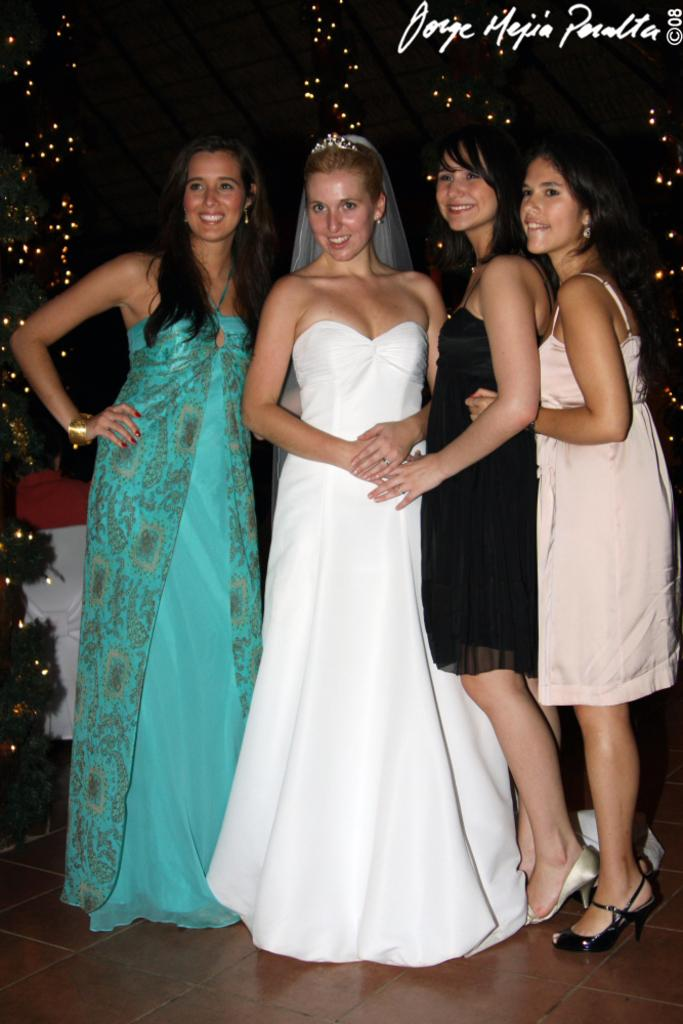How many people are in the image? There are four women in the image. What are the women doing in the image? The women are standing. Is there any text or image in the image? Yes, there is text or an image in the right top corner of the image. What type of insurance is being advertised in the image? There is no insurance being advertised in the image; it only features four women standing and text or an image in the right top corner. 